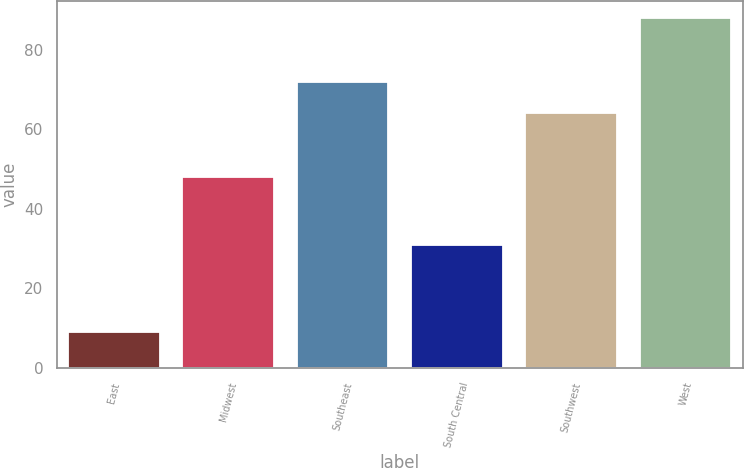Convert chart to OTSL. <chart><loc_0><loc_0><loc_500><loc_500><bar_chart><fcel>East<fcel>Midwest<fcel>Southeast<fcel>South Central<fcel>Southwest<fcel>West<nl><fcel>9<fcel>48<fcel>72<fcel>31<fcel>64<fcel>88<nl></chart> 